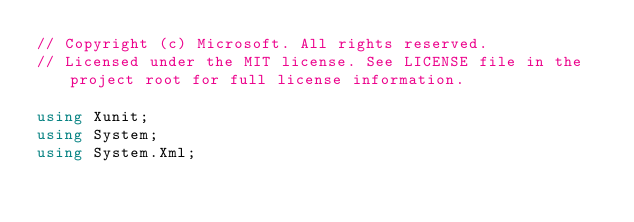<code> <loc_0><loc_0><loc_500><loc_500><_C#_>// Copyright (c) Microsoft. All rights reserved.
// Licensed under the MIT license. See LICENSE file in the project root for full license information.

using Xunit;
using System;
using System.Xml;
</code> 